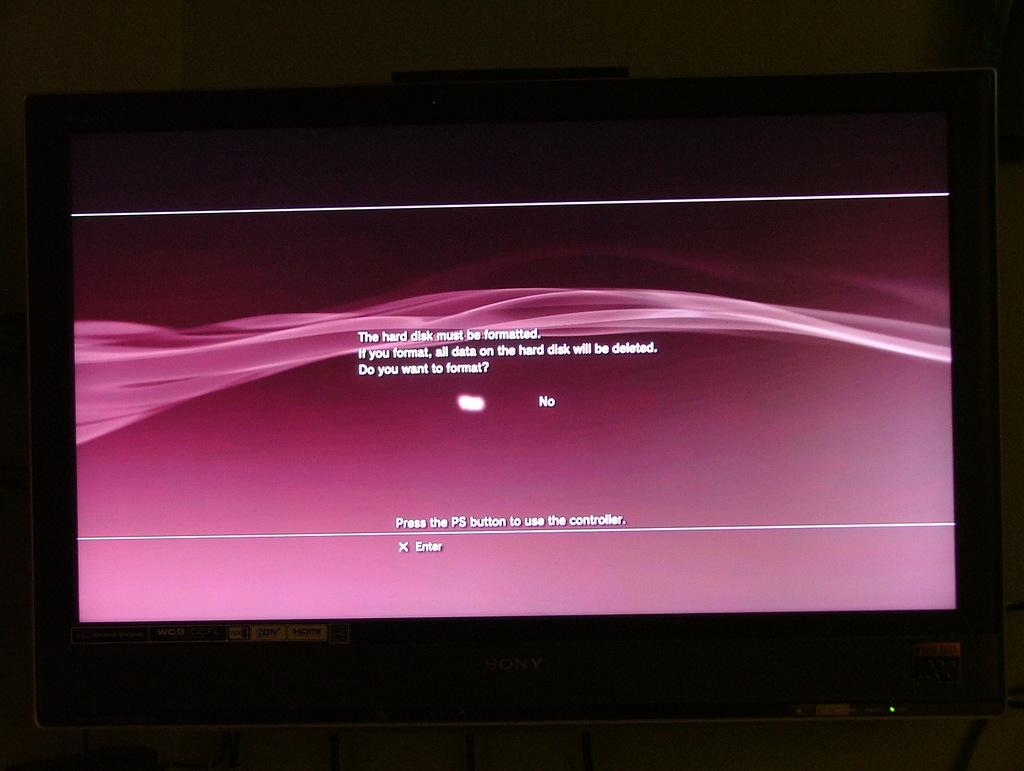<image>
Share a concise interpretation of the image provided. Playstation loading up on a television asking you to select yes or no 